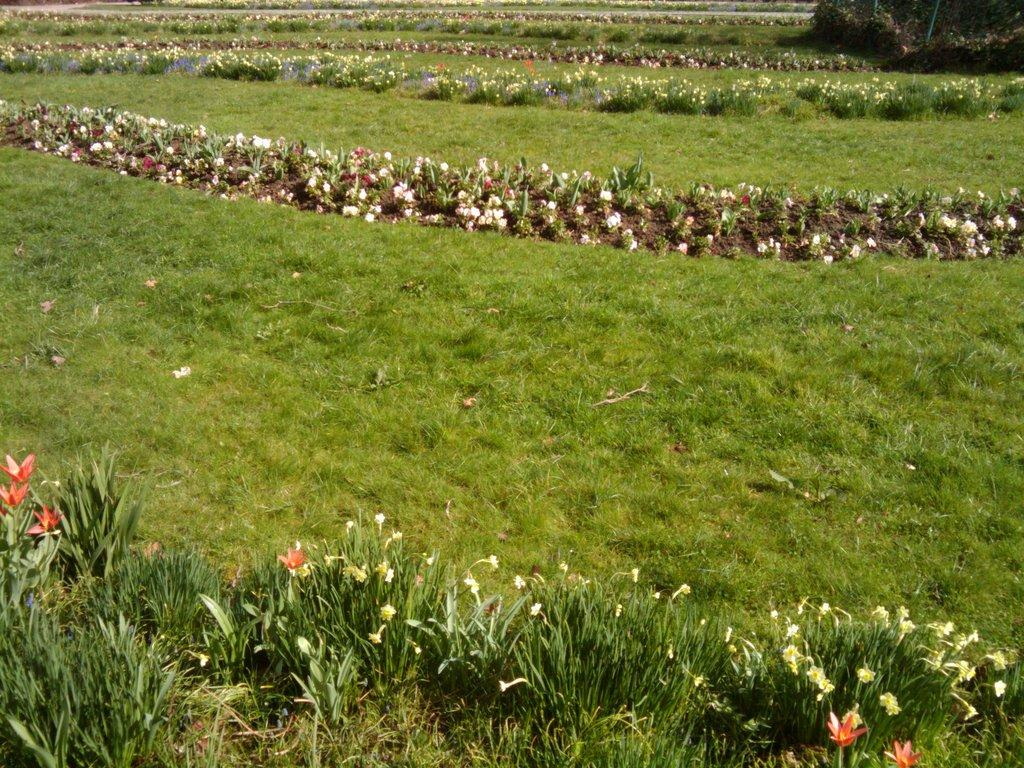What type of vegetation is present in the image? There is grass and plants with flowers in the image. Can you describe the plants with flowers? The plants with flowers are visible among the grass in the image. What can be seen in the background of the image? There are objects visible in the background of the image. What is the rate at which the knee is bending in the image? There is no knee present in the image, so it is not possible to determine the rate at which it might be bending. 